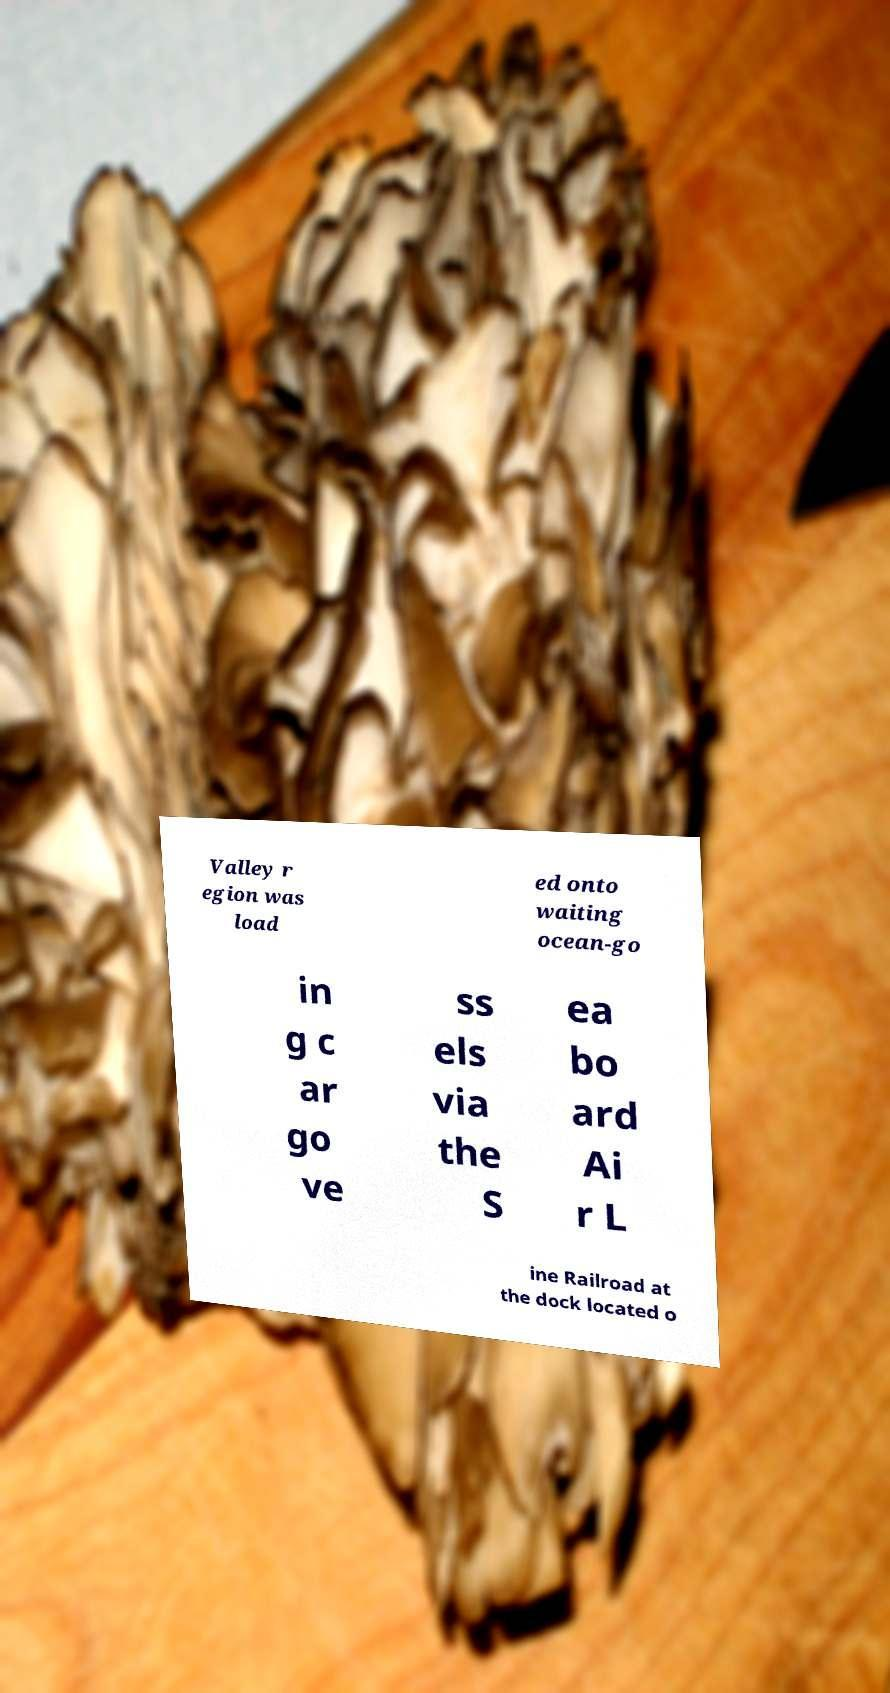Please read and relay the text visible in this image. What does it say? Valley r egion was load ed onto waiting ocean-go in g c ar go ve ss els via the S ea bo ard Ai r L ine Railroad at the dock located o 